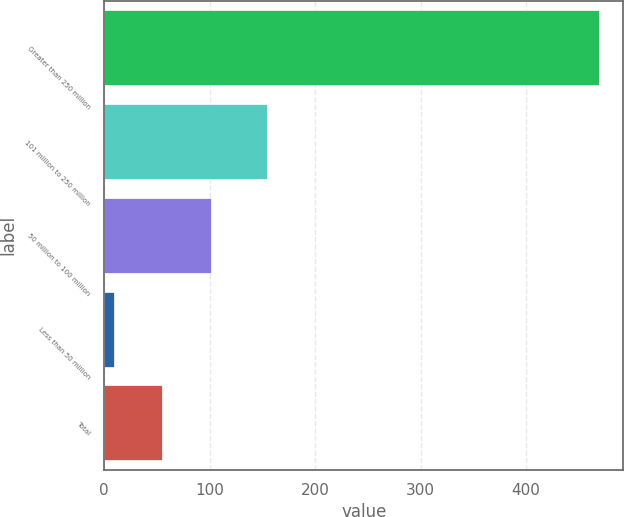Convert chart to OTSL. <chart><loc_0><loc_0><loc_500><loc_500><bar_chart><fcel>Greater than 250 million<fcel>101 million to 250 million<fcel>50 million to 100 million<fcel>Less than 50 million<fcel>Total<nl><fcel>469<fcel>154<fcel>101<fcel>9<fcel>55<nl></chart> 